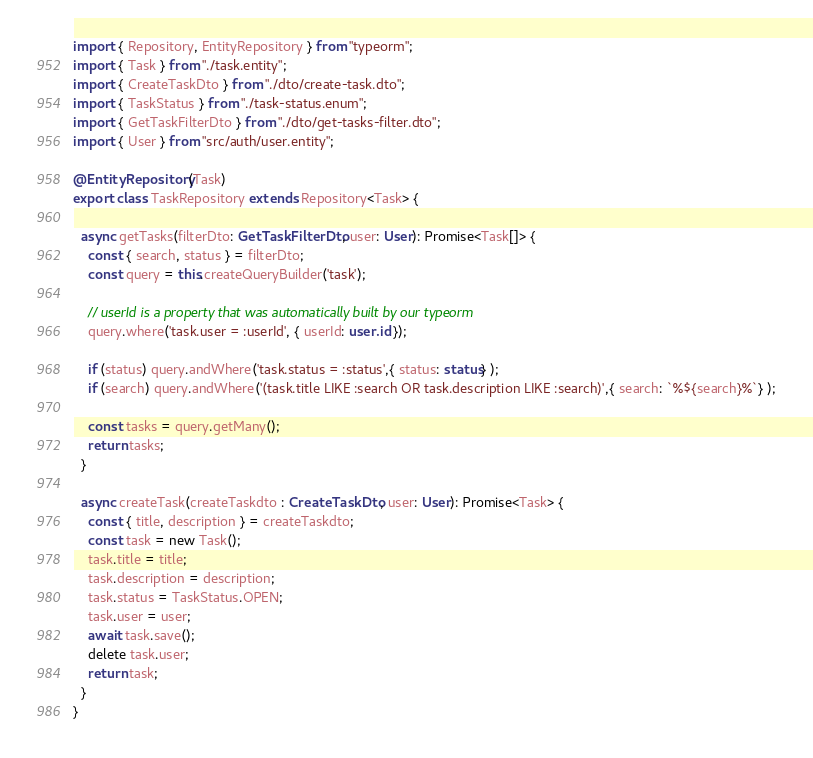<code> <loc_0><loc_0><loc_500><loc_500><_TypeScript_>import { Repository, EntityRepository } from "typeorm";
import { Task } from "./task.entity";
import { CreateTaskDto } from "./dto/create-task.dto";
import { TaskStatus } from "./task-status.enum";
import { GetTaskFilterDto } from "./dto/get-tasks-filter.dto";
import { User } from "src/auth/user.entity";

@EntityRepository(Task)
export class TaskRepository extends Repository<Task> {

  async getTasks(filterDto: GetTaskFilterDto, user: User): Promise<Task[]> {
    const { search, status } = filterDto;
    const query = this.createQueryBuilder('task');

    // userId is a property that was automatically built by our typeorm
    query.where('task.user = :userId', { userId: user.id });

    if (status) query.andWhere('task.status = :status',{ status: status} );
    if (search) query.andWhere('(task.title LIKE :search OR task.description LIKE :search)',{ search: `%${search}%`} );

    const tasks = query.getMany();
    return tasks;
  }

  async createTask(createTaskdto : CreateTaskDto, user: User): Promise<Task> {
    const { title, description } = createTaskdto;
    const task = new Task();
    task.title = title;
    task.description = description;
    task.status = TaskStatus.OPEN;
    task.user = user;
    await task.save();
    delete task.user;
    return task;
  }
}
</code> 